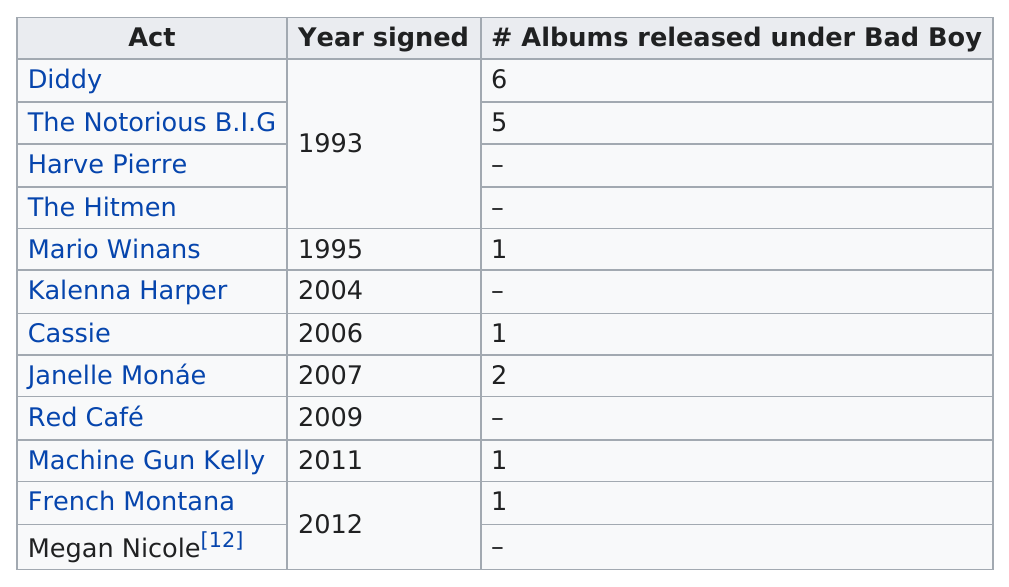Point out several critical features in this image. Diddy has released six albums under Bad Boy Records. French Montana released one album under Bad Boy. In 1993, both Diddy and the Notorious B.I.G. signed with Bad Boy Records. Diddy, also known as Sean Combs, had six albums under the label Bad Boy. Sean "Diddy" Combs is known for having the most albums released under the Bad Boy record label. 